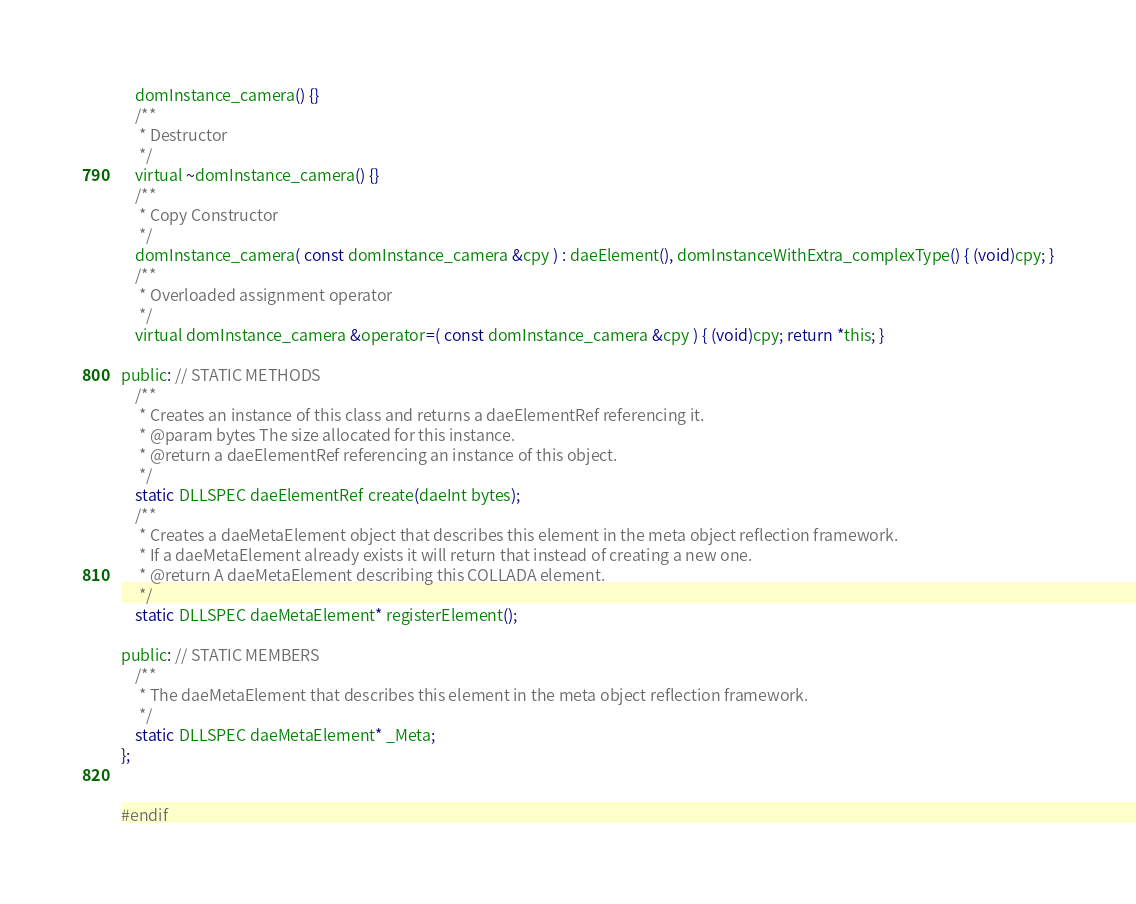<code> <loc_0><loc_0><loc_500><loc_500><_C_>	domInstance_camera() {}
	/**
	 * Destructor
	 */
	virtual ~domInstance_camera() {}
	/**
	 * Copy Constructor
	 */
	domInstance_camera( const domInstance_camera &cpy ) : daeElement(), domInstanceWithExtra_complexType() { (void)cpy; }
	/**
	 * Overloaded assignment operator
	 */
	virtual domInstance_camera &operator=( const domInstance_camera &cpy ) { (void)cpy; return *this; }

public: // STATIC METHODS
	/**
	 * Creates an instance of this class and returns a daeElementRef referencing it.
	 * @param bytes The size allocated for this instance.
	 * @return a daeElementRef referencing an instance of this object.
	 */
	static DLLSPEC daeElementRef create(daeInt bytes);
	/**
	 * Creates a daeMetaElement object that describes this element in the meta object reflection framework.
	 * If a daeMetaElement already exists it will return that instead of creating a new one. 
	 * @return A daeMetaElement describing this COLLADA element.
	 */
	static DLLSPEC daeMetaElement* registerElement();

public: // STATIC MEMBERS
	/**
	 * The daeMetaElement that describes this element in the meta object reflection framework.
	 */
	static DLLSPEC daeMetaElement* _Meta;
};


#endif
</code> 